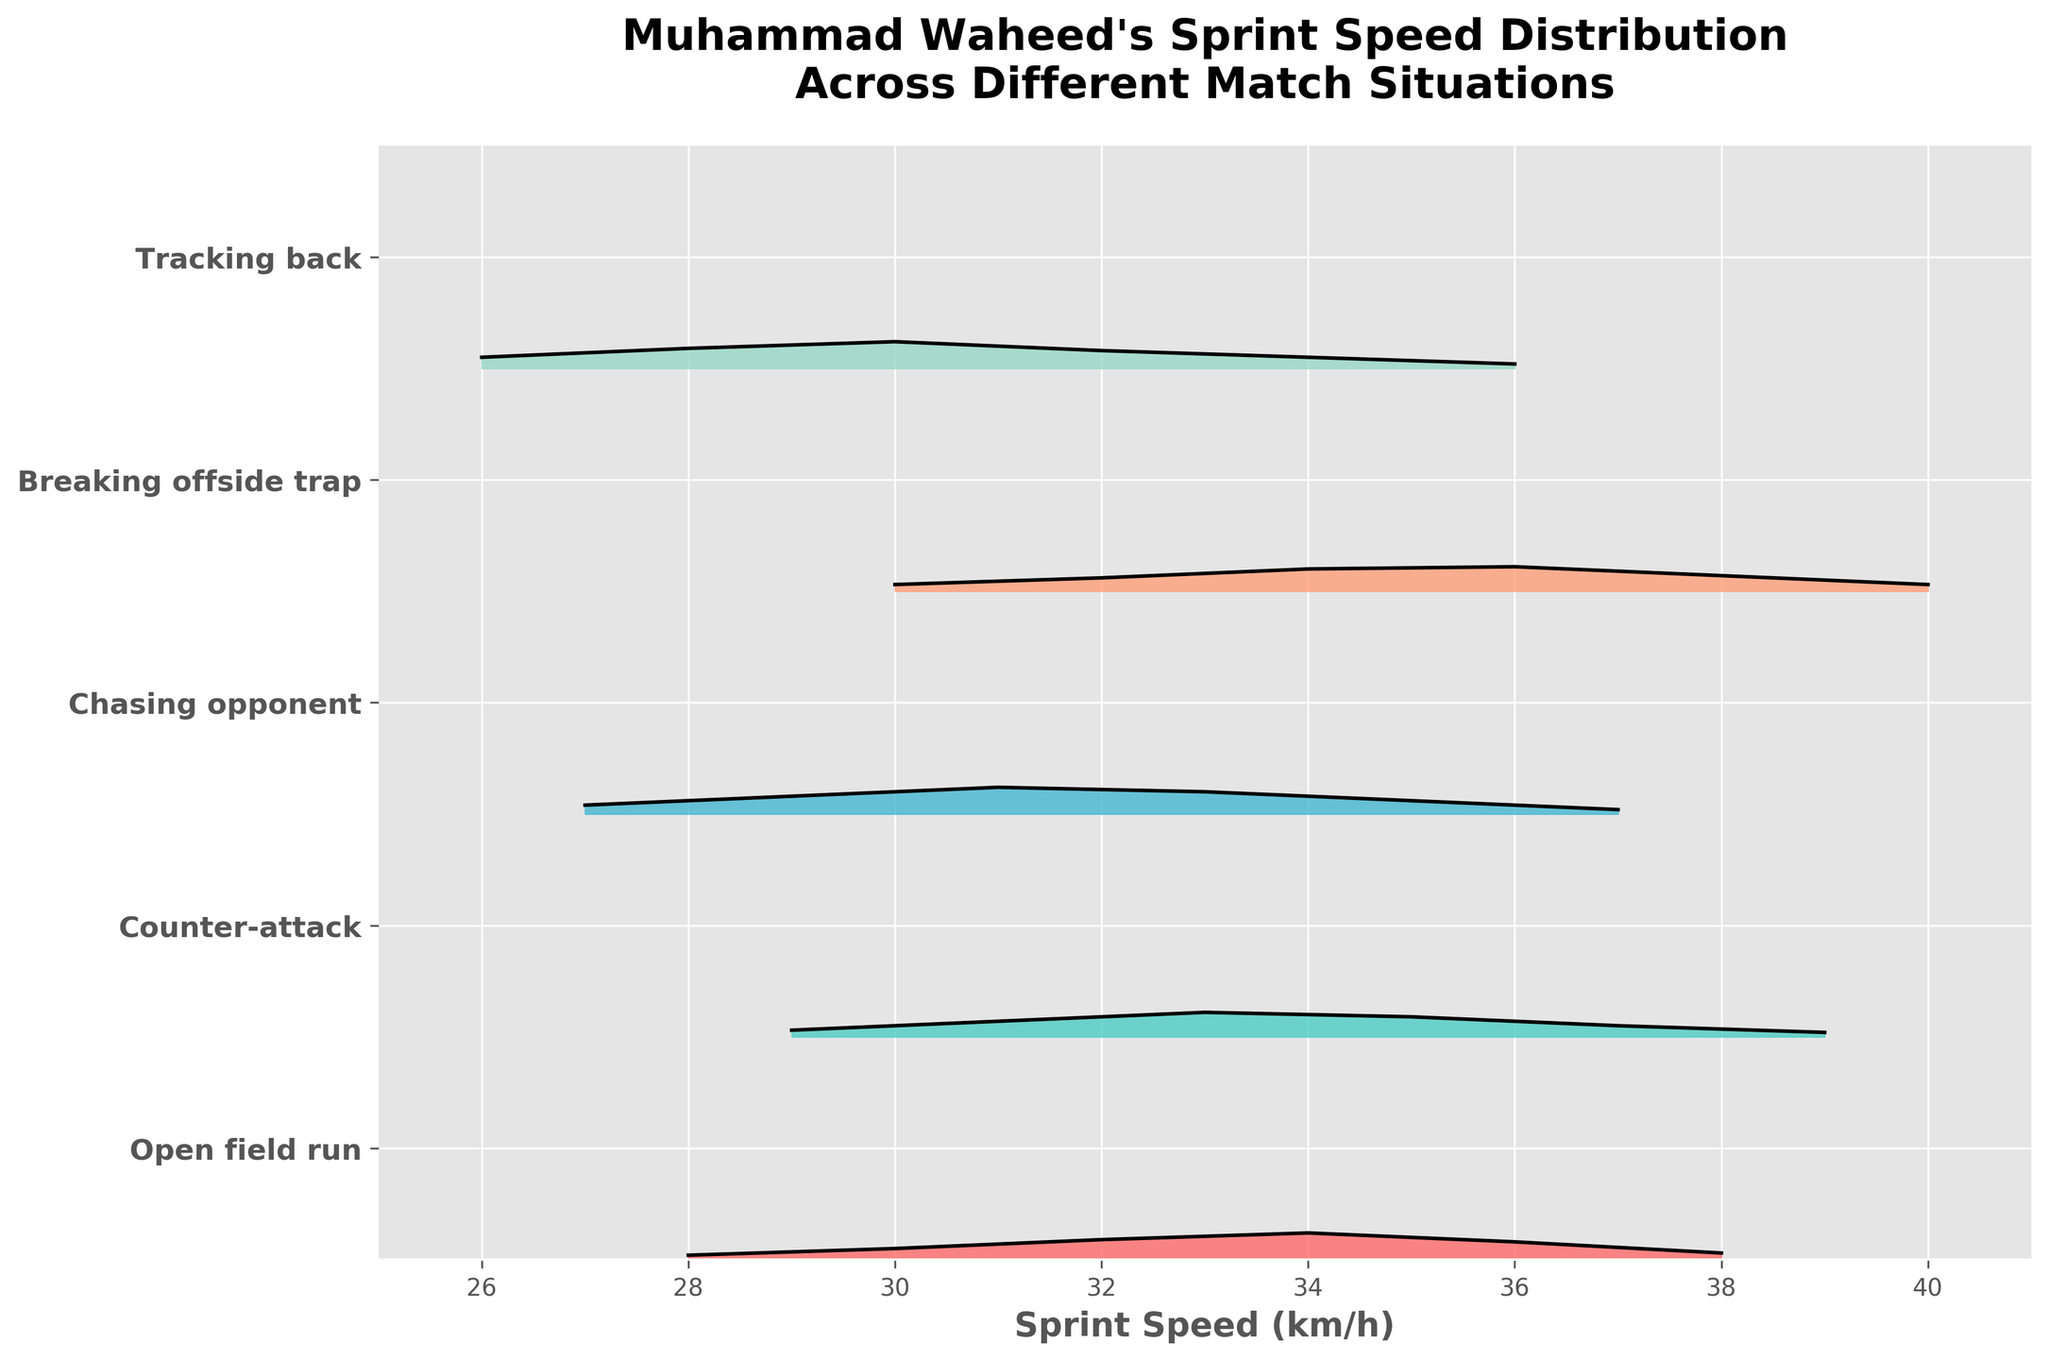What is the title of the figure? The title is positioned at the top of the figure, indicating what the plot is about.
Answer: Muhammad Waheed's Sprint Speed Distribution Across Different Match Situations What is the highest density value for the "Open field run" situation? Look for the "Open field run" ridgeline plot and identify the peak density value on the y-axis.
Answer: 0.12 Which match situation shows the highest sprint speed value? Identify the maximum speed value across different situations in the x-axis.
Answer: Breaking offside trap What is the range of sprint speeds displayed on the x-axis? Observe the lowest and highest values marked on the x-axis.
Answer: 25 to 40 km/h Which match situation has the second-highest peak density value? Examine the peak density values for each match situation and find the second-highest one.
Answer: Counter-attack How does the peak density of "Chasing opponent" compare to "Tracking back"? Compare the peak values of the ridgeline plots for both situations.
Answer: Higher for Chasing opponent What is the most common sprint speed for "Tracking back" and what is its density value? Find the speed with the highest density for "Tracking back" and note the corresponding density value.
Answer: 30 km/h and 0.12 Which match situation has a peak sprint speed density at 34 km/h? Look at the ridgeline plot for the peak density occurring at the speed of 34 km/h.
Answer: Open field run Which match situation shows a wider spread of sprint speeds? Compare the width of the ridgeline plots to identify the situation with a broader range of speeds.
Answer: Breaking offside trap What is the average peak density value across all match situations? Sum the peak density values for all situations and divide by the number of situations.
Answer: 0.086 